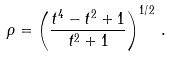Convert formula to latex. <formula><loc_0><loc_0><loc_500><loc_500>\rho = \left ( \frac { t ^ { 4 } - t ^ { 2 } + 1 } { t ^ { 2 } + 1 } \right ) ^ { 1 / 2 } \, .</formula> 